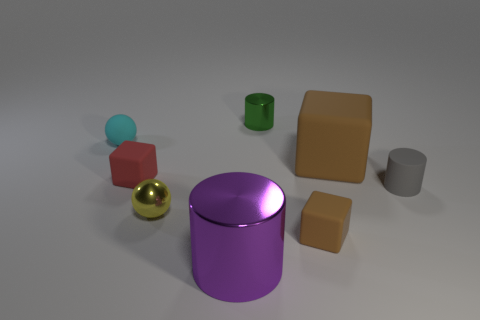Which objects in this image appear to be the tallest and the shortest? The purple cylinder appears to be the tallest object, while the smallest object seems to be the golden sphere. 